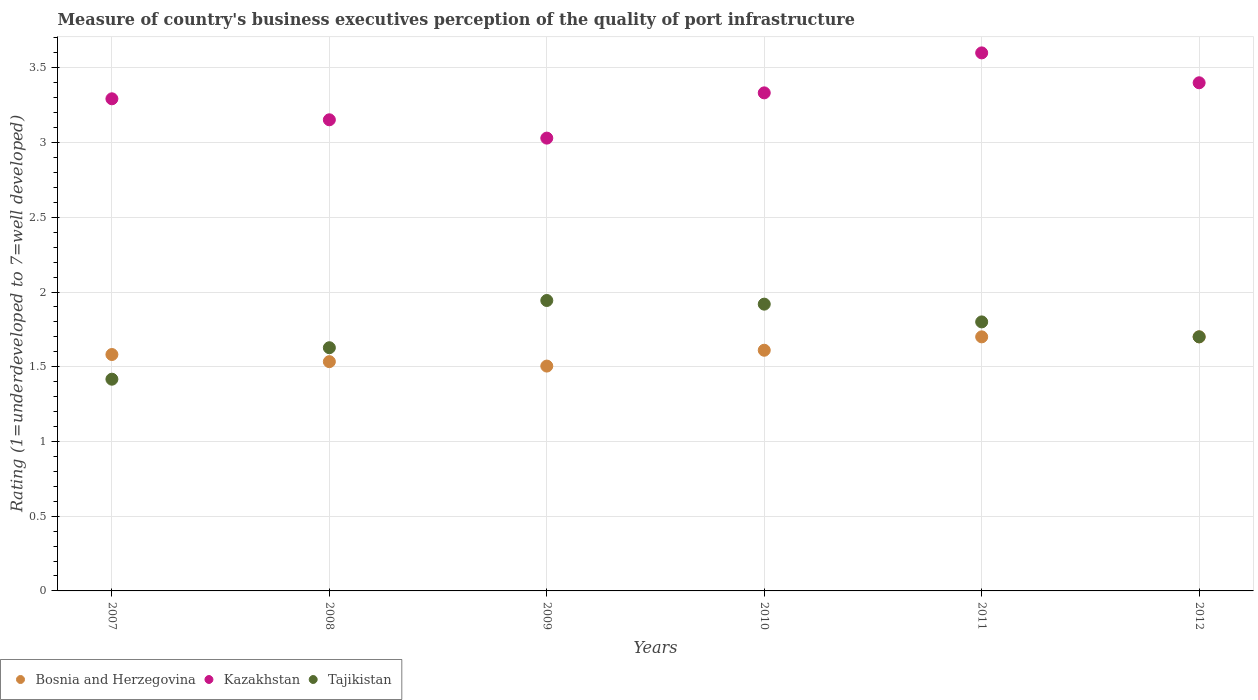How many different coloured dotlines are there?
Ensure brevity in your answer.  3. Is the number of dotlines equal to the number of legend labels?
Your answer should be very brief. Yes. What is the ratings of the quality of port infrastructure in Kazakhstan in 2007?
Offer a very short reply. 3.29. Across all years, what is the maximum ratings of the quality of port infrastructure in Tajikistan?
Give a very brief answer. 1.94. Across all years, what is the minimum ratings of the quality of port infrastructure in Tajikistan?
Your response must be concise. 1.42. In which year was the ratings of the quality of port infrastructure in Kazakhstan minimum?
Ensure brevity in your answer.  2009. What is the total ratings of the quality of port infrastructure in Bosnia and Herzegovina in the graph?
Ensure brevity in your answer.  9.63. What is the difference between the ratings of the quality of port infrastructure in Bosnia and Herzegovina in 2008 and that in 2010?
Provide a short and direct response. -0.08. What is the difference between the ratings of the quality of port infrastructure in Tajikistan in 2012 and the ratings of the quality of port infrastructure in Kazakhstan in 2009?
Offer a very short reply. -1.33. What is the average ratings of the quality of port infrastructure in Tajikistan per year?
Offer a very short reply. 1.73. In the year 2008, what is the difference between the ratings of the quality of port infrastructure in Kazakhstan and ratings of the quality of port infrastructure in Tajikistan?
Give a very brief answer. 1.53. What is the ratio of the ratings of the quality of port infrastructure in Bosnia and Herzegovina in 2009 to that in 2011?
Offer a terse response. 0.88. What is the difference between the highest and the second highest ratings of the quality of port infrastructure in Bosnia and Herzegovina?
Your answer should be very brief. 0. What is the difference between the highest and the lowest ratings of the quality of port infrastructure in Kazakhstan?
Provide a short and direct response. 0.57. Is the sum of the ratings of the quality of port infrastructure in Tajikistan in 2008 and 2009 greater than the maximum ratings of the quality of port infrastructure in Bosnia and Herzegovina across all years?
Make the answer very short. Yes. Does the ratings of the quality of port infrastructure in Bosnia and Herzegovina monotonically increase over the years?
Your answer should be very brief. No. Is the ratings of the quality of port infrastructure in Bosnia and Herzegovina strictly greater than the ratings of the quality of port infrastructure in Tajikistan over the years?
Your answer should be very brief. No. Is the ratings of the quality of port infrastructure in Bosnia and Herzegovina strictly less than the ratings of the quality of port infrastructure in Tajikistan over the years?
Make the answer very short. No. How many dotlines are there?
Provide a short and direct response. 3. How many years are there in the graph?
Your answer should be compact. 6. What is the difference between two consecutive major ticks on the Y-axis?
Provide a short and direct response. 0.5. Are the values on the major ticks of Y-axis written in scientific E-notation?
Your answer should be very brief. No. Does the graph contain grids?
Provide a succinct answer. Yes. What is the title of the graph?
Provide a succinct answer. Measure of country's business executives perception of the quality of port infrastructure. Does "Italy" appear as one of the legend labels in the graph?
Your response must be concise. No. What is the label or title of the Y-axis?
Keep it short and to the point. Rating (1=underdeveloped to 7=well developed). What is the Rating (1=underdeveloped to 7=well developed) of Bosnia and Herzegovina in 2007?
Make the answer very short. 1.58. What is the Rating (1=underdeveloped to 7=well developed) in Kazakhstan in 2007?
Ensure brevity in your answer.  3.29. What is the Rating (1=underdeveloped to 7=well developed) in Tajikistan in 2007?
Your answer should be compact. 1.42. What is the Rating (1=underdeveloped to 7=well developed) of Bosnia and Herzegovina in 2008?
Your answer should be compact. 1.53. What is the Rating (1=underdeveloped to 7=well developed) in Kazakhstan in 2008?
Provide a succinct answer. 3.15. What is the Rating (1=underdeveloped to 7=well developed) in Tajikistan in 2008?
Your answer should be very brief. 1.63. What is the Rating (1=underdeveloped to 7=well developed) of Bosnia and Herzegovina in 2009?
Offer a terse response. 1.5. What is the Rating (1=underdeveloped to 7=well developed) of Kazakhstan in 2009?
Provide a succinct answer. 3.03. What is the Rating (1=underdeveloped to 7=well developed) in Tajikistan in 2009?
Provide a short and direct response. 1.94. What is the Rating (1=underdeveloped to 7=well developed) of Bosnia and Herzegovina in 2010?
Keep it short and to the point. 1.61. What is the Rating (1=underdeveloped to 7=well developed) of Kazakhstan in 2010?
Offer a terse response. 3.33. What is the Rating (1=underdeveloped to 7=well developed) of Tajikistan in 2010?
Provide a succinct answer. 1.92. What is the Rating (1=underdeveloped to 7=well developed) in Bosnia and Herzegovina in 2011?
Your answer should be very brief. 1.7. Across all years, what is the maximum Rating (1=underdeveloped to 7=well developed) in Kazakhstan?
Ensure brevity in your answer.  3.6. Across all years, what is the maximum Rating (1=underdeveloped to 7=well developed) in Tajikistan?
Your answer should be compact. 1.94. Across all years, what is the minimum Rating (1=underdeveloped to 7=well developed) in Bosnia and Herzegovina?
Make the answer very short. 1.5. Across all years, what is the minimum Rating (1=underdeveloped to 7=well developed) of Kazakhstan?
Give a very brief answer. 3.03. Across all years, what is the minimum Rating (1=underdeveloped to 7=well developed) in Tajikistan?
Provide a short and direct response. 1.42. What is the total Rating (1=underdeveloped to 7=well developed) of Bosnia and Herzegovina in the graph?
Keep it short and to the point. 9.63. What is the total Rating (1=underdeveloped to 7=well developed) of Kazakhstan in the graph?
Provide a short and direct response. 19.81. What is the total Rating (1=underdeveloped to 7=well developed) in Tajikistan in the graph?
Give a very brief answer. 10.41. What is the difference between the Rating (1=underdeveloped to 7=well developed) of Bosnia and Herzegovina in 2007 and that in 2008?
Provide a short and direct response. 0.05. What is the difference between the Rating (1=underdeveloped to 7=well developed) in Kazakhstan in 2007 and that in 2008?
Offer a very short reply. 0.14. What is the difference between the Rating (1=underdeveloped to 7=well developed) of Tajikistan in 2007 and that in 2008?
Your answer should be compact. -0.21. What is the difference between the Rating (1=underdeveloped to 7=well developed) in Bosnia and Herzegovina in 2007 and that in 2009?
Ensure brevity in your answer.  0.08. What is the difference between the Rating (1=underdeveloped to 7=well developed) in Kazakhstan in 2007 and that in 2009?
Offer a very short reply. 0.26. What is the difference between the Rating (1=underdeveloped to 7=well developed) in Tajikistan in 2007 and that in 2009?
Keep it short and to the point. -0.53. What is the difference between the Rating (1=underdeveloped to 7=well developed) of Bosnia and Herzegovina in 2007 and that in 2010?
Keep it short and to the point. -0.03. What is the difference between the Rating (1=underdeveloped to 7=well developed) in Kazakhstan in 2007 and that in 2010?
Offer a very short reply. -0.04. What is the difference between the Rating (1=underdeveloped to 7=well developed) of Tajikistan in 2007 and that in 2010?
Provide a short and direct response. -0.5. What is the difference between the Rating (1=underdeveloped to 7=well developed) in Bosnia and Herzegovina in 2007 and that in 2011?
Keep it short and to the point. -0.12. What is the difference between the Rating (1=underdeveloped to 7=well developed) of Kazakhstan in 2007 and that in 2011?
Your answer should be compact. -0.31. What is the difference between the Rating (1=underdeveloped to 7=well developed) in Tajikistan in 2007 and that in 2011?
Your answer should be compact. -0.38. What is the difference between the Rating (1=underdeveloped to 7=well developed) in Bosnia and Herzegovina in 2007 and that in 2012?
Provide a short and direct response. -0.12. What is the difference between the Rating (1=underdeveloped to 7=well developed) of Kazakhstan in 2007 and that in 2012?
Make the answer very short. -0.11. What is the difference between the Rating (1=underdeveloped to 7=well developed) of Tajikistan in 2007 and that in 2012?
Make the answer very short. -0.28. What is the difference between the Rating (1=underdeveloped to 7=well developed) in Bosnia and Herzegovina in 2008 and that in 2009?
Your answer should be very brief. 0.03. What is the difference between the Rating (1=underdeveloped to 7=well developed) in Kazakhstan in 2008 and that in 2009?
Ensure brevity in your answer.  0.12. What is the difference between the Rating (1=underdeveloped to 7=well developed) in Tajikistan in 2008 and that in 2009?
Your answer should be compact. -0.32. What is the difference between the Rating (1=underdeveloped to 7=well developed) in Bosnia and Herzegovina in 2008 and that in 2010?
Provide a short and direct response. -0.08. What is the difference between the Rating (1=underdeveloped to 7=well developed) of Kazakhstan in 2008 and that in 2010?
Offer a terse response. -0.18. What is the difference between the Rating (1=underdeveloped to 7=well developed) in Tajikistan in 2008 and that in 2010?
Keep it short and to the point. -0.29. What is the difference between the Rating (1=underdeveloped to 7=well developed) of Bosnia and Herzegovina in 2008 and that in 2011?
Provide a succinct answer. -0.17. What is the difference between the Rating (1=underdeveloped to 7=well developed) in Kazakhstan in 2008 and that in 2011?
Offer a terse response. -0.45. What is the difference between the Rating (1=underdeveloped to 7=well developed) in Tajikistan in 2008 and that in 2011?
Give a very brief answer. -0.17. What is the difference between the Rating (1=underdeveloped to 7=well developed) in Bosnia and Herzegovina in 2008 and that in 2012?
Keep it short and to the point. -0.17. What is the difference between the Rating (1=underdeveloped to 7=well developed) of Kazakhstan in 2008 and that in 2012?
Offer a very short reply. -0.25. What is the difference between the Rating (1=underdeveloped to 7=well developed) of Tajikistan in 2008 and that in 2012?
Keep it short and to the point. -0.07. What is the difference between the Rating (1=underdeveloped to 7=well developed) of Bosnia and Herzegovina in 2009 and that in 2010?
Make the answer very short. -0.11. What is the difference between the Rating (1=underdeveloped to 7=well developed) of Kazakhstan in 2009 and that in 2010?
Your answer should be compact. -0.3. What is the difference between the Rating (1=underdeveloped to 7=well developed) of Tajikistan in 2009 and that in 2010?
Offer a terse response. 0.02. What is the difference between the Rating (1=underdeveloped to 7=well developed) in Bosnia and Herzegovina in 2009 and that in 2011?
Make the answer very short. -0.2. What is the difference between the Rating (1=underdeveloped to 7=well developed) in Kazakhstan in 2009 and that in 2011?
Offer a very short reply. -0.57. What is the difference between the Rating (1=underdeveloped to 7=well developed) of Tajikistan in 2009 and that in 2011?
Keep it short and to the point. 0.14. What is the difference between the Rating (1=underdeveloped to 7=well developed) of Bosnia and Herzegovina in 2009 and that in 2012?
Offer a very short reply. -0.2. What is the difference between the Rating (1=underdeveloped to 7=well developed) in Kazakhstan in 2009 and that in 2012?
Your response must be concise. -0.37. What is the difference between the Rating (1=underdeveloped to 7=well developed) in Tajikistan in 2009 and that in 2012?
Offer a terse response. 0.24. What is the difference between the Rating (1=underdeveloped to 7=well developed) of Bosnia and Herzegovina in 2010 and that in 2011?
Give a very brief answer. -0.09. What is the difference between the Rating (1=underdeveloped to 7=well developed) of Kazakhstan in 2010 and that in 2011?
Keep it short and to the point. -0.27. What is the difference between the Rating (1=underdeveloped to 7=well developed) of Tajikistan in 2010 and that in 2011?
Provide a short and direct response. 0.12. What is the difference between the Rating (1=underdeveloped to 7=well developed) of Bosnia and Herzegovina in 2010 and that in 2012?
Your answer should be very brief. -0.09. What is the difference between the Rating (1=underdeveloped to 7=well developed) in Kazakhstan in 2010 and that in 2012?
Ensure brevity in your answer.  -0.07. What is the difference between the Rating (1=underdeveloped to 7=well developed) in Tajikistan in 2010 and that in 2012?
Keep it short and to the point. 0.22. What is the difference between the Rating (1=underdeveloped to 7=well developed) in Bosnia and Herzegovina in 2011 and that in 2012?
Ensure brevity in your answer.  0. What is the difference between the Rating (1=underdeveloped to 7=well developed) in Bosnia and Herzegovina in 2007 and the Rating (1=underdeveloped to 7=well developed) in Kazakhstan in 2008?
Provide a short and direct response. -1.57. What is the difference between the Rating (1=underdeveloped to 7=well developed) in Bosnia and Herzegovina in 2007 and the Rating (1=underdeveloped to 7=well developed) in Tajikistan in 2008?
Provide a succinct answer. -0.05. What is the difference between the Rating (1=underdeveloped to 7=well developed) of Kazakhstan in 2007 and the Rating (1=underdeveloped to 7=well developed) of Tajikistan in 2008?
Your response must be concise. 1.67. What is the difference between the Rating (1=underdeveloped to 7=well developed) in Bosnia and Herzegovina in 2007 and the Rating (1=underdeveloped to 7=well developed) in Kazakhstan in 2009?
Your response must be concise. -1.45. What is the difference between the Rating (1=underdeveloped to 7=well developed) in Bosnia and Herzegovina in 2007 and the Rating (1=underdeveloped to 7=well developed) in Tajikistan in 2009?
Give a very brief answer. -0.36. What is the difference between the Rating (1=underdeveloped to 7=well developed) of Kazakhstan in 2007 and the Rating (1=underdeveloped to 7=well developed) of Tajikistan in 2009?
Give a very brief answer. 1.35. What is the difference between the Rating (1=underdeveloped to 7=well developed) in Bosnia and Herzegovina in 2007 and the Rating (1=underdeveloped to 7=well developed) in Kazakhstan in 2010?
Provide a succinct answer. -1.75. What is the difference between the Rating (1=underdeveloped to 7=well developed) of Bosnia and Herzegovina in 2007 and the Rating (1=underdeveloped to 7=well developed) of Tajikistan in 2010?
Your answer should be very brief. -0.34. What is the difference between the Rating (1=underdeveloped to 7=well developed) in Kazakhstan in 2007 and the Rating (1=underdeveloped to 7=well developed) in Tajikistan in 2010?
Offer a terse response. 1.37. What is the difference between the Rating (1=underdeveloped to 7=well developed) in Bosnia and Herzegovina in 2007 and the Rating (1=underdeveloped to 7=well developed) in Kazakhstan in 2011?
Your answer should be very brief. -2.02. What is the difference between the Rating (1=underdeveloped to 7=well developed) of Bosnia and Herzegovina in 2007 and the Rating (1=underdeveloped to 7=well developed) of Tajikistan in 2011?
Provide a succinct answer. -0.22. What is the difference between the Rating (1=underdeveloped to 7=well developed) in Kazakhstan in 2007 and the Rating (1=underdeveloped to 7=well developed) in Tajikistan in 2011?
Give a very brief answer. 1.49. What is the difference between the Rating (1=underdeveloped to 7=well developed) of Bosnia and Herzegovina in 2007 and the Rating (1=underdeveloped to 7=well developed) of Kazakhstan in 2012?
Provide a short and direct response. -1.82. What is the difference between the Rating (1=underdeveloped to 7=well developed) in Bosnia and Herzegovina in 2007 and the Rating (1=underdeveloped to 7=well developed) in Tajikistan in 2012?
Make the answer very short. -0.12. What is the difference between the Rating (1=underdeveloped to 7=well developed) in Kazakhstan in 2007 and the Rating (1=underdeveloped to 7=well developed) in Tajikistan in 2012?
Ensure brevity in your answer.  1.59. What is the difference between the Rating (1=underdeveloped to 7=well developed) of Bosnia and Herzegovina in 2008 and the Rating (1=underdeveloped to 7=well developed) of Kazakhstan in 2009?
Offer a terse response. -1.5. What is the difference between the Rating (1=underdeveloped to 7=well developed) in Bosnia and Herzegovina in 2008 and the Rating (1=underdeveloped to 7=well developed) in Tajikistan in 2009?
Provide a succinct answer. -0.41. What is the difference between the Rating (1=underdeveloped to 7=well developed) of Kazakhstan in 2008 and the Rating (1=underdeveloped to 7=well developed) of Tajikistan in 2009?
Your answer should be compact. 1.21. What is the difference between the Rating (1=underdeveloped to 7=well developed) of Bosnia and Herzegovina in 2008 and the Rating (1=underdeveloped to 7=well developed) of Kazakhstan in 2010?
Offer a terse response. -1.8. What is the difference between the Rating (1=underdeveloped to 7=well developed) in Bosnia and Herzegovina in 2008 and the Rating (1=underdeveloped to 7=well developed) in Tajikistan in 2010?
Provide a succinct answer. -0.38. What is the difference between the Rating (1=underdeveloped to 7=well developed) of Kazakhstan in 2008 and the Rating (1=underdeveloped to 7=well developed) of Tajikistan in 2010?
Keep it short and to the point. 1.23. What is the difference between the Rating (1=underdeveloped to 7=well developed) in Bosnia and Herzegovina in 2008 and the Rating (1=underdeveloped to 7=well developed) in Kazakhstan in 2011?
Your response must be concise. -2.07. What is the difference between the Rating (1=underdeveloped to 7=well developed) in Bosnia and Herzegovina in 2008 and the Rating (1=underdeveloped to 7=well developed) in Tajikistan in 2011?
Your answer should be very brief. -0.27. What is the difference between the Rating (1=underdeveloped to 7=well developed) in Kazakhstan in 2008 and the Rating (1=underdeveloped to 7=well developed) in Tajikistan in 2011?
Provide a short and direct response. 1.35. What is the difference between the Rating (1=underdeveloped to 7=well developed) in Bosnia and Herzegovina in 2008 and the Rating (1=underdeveloped to 7=well developed) in Kazakhstan in 2012?
Offer a terse response. -1.87. What is the difference between the Rating (1=underdeveloped to 7=well developed) of Bosnia and Herzegovina in 2008 and the Rating (1=underdeveloped to 7=well developed) of Tajikistan in 2012?
Keep it short and to the point. -0.17. What is the difference between the Rating (1=underdeveloped to 7=well developed) of Kazakhstan in 2008 and the Rating (1=underdeveloped to 7=well developed) of Tajikistan in 2012?
Ensure brevity in your answer.  1.45. What is the difference between the Rating (1=underdeveloped to 7=well developed) in Bosnia and Herzegovina in 2009 and the Rating (1=underdeveloped to 7=well developed) in Kazakhstan in 2010?
Keep it short and to the point. -1.83. What is the difference between the Rating (1=underdeveloped to 7=well developed) of Bosnia and Herzegovina in 2009 and the Rating (1=underdeveloped to 7=well developed) of Tajikistan in 2010?
Your answer should be very brief. -0.41. What is the difference between the Rating (1=underdeveloped to 7=well developed) in Kazakhstan in 2009 and the Rating (1=underdeveloped to 7=well developed) in Tajikistan in 2010?
Ensure brevity in your answer.  1.11. What is the difference between the Rating (1=underdeveloped to 7=well developed) in Bosnia and Herzegovina in 2009 and the Rating (1=underdeveloped to 7=well developed) in Kazakhstan in 2011?
Your answer should be very brief. -2.1. What is the difference between the Rating (1=underdeveloped to 7=well developed) of Bosnia and Herzegovina in 2009 and the Rating (1=underdeveloped to 7=well developed) of Tajikistan in 2011?
Offer a very short reply. -0.3. What is the difference between the Rating (1=underdeveloped to 7=well developed) of Kazakhstan in 2009 and the Rating (1=underdeveloped to 7=well developed) of Tajikistan in 2011?
Keep it short and to the point. 1.23. What is the difference between the Rating (1=underdeveloped to 7=well developed) in Bosnia and Herzegovina in 2009 and the Rating (1=underdeveloped to 7=well developed) in Kazakhstan in 2012?
Your response must be concise. -1.9. What is the difference between the Rating (1=underdeveloped to 7=well developed) in Bosnia and Herzegovina in 2009 and the Rating (1=underdeveloped to 7=well developed) in Tajikistan in 2012?
Offer a very short reply. -0.2. What is the difference between the Rating (1=underdeveloped to 7=well developed) in Kazakhstan in 2009 and the Rating (1=underdeveloped to 7=well developed) in Tajikistan in 2012?
Keep it short and to the point. 1.33. What is the difference between the Rating (1=underdeveloped to 7=well developed) of Bosnia and Herzegovina in 2010 and the Rating (1=underdeveloped to 7=well developed) of Kazakhstan in 2011?
Offer a terse response. -1.99. What is the difference between the Rating (1=underdeveloped to 7=well developed) in Bosnia and Herzegovina in 2010 and the Rating (1=underdeveloped to 7=well developed) in Tajikistan in 2011?
Ensure brevity in your answer.  -0.19. What is the difference between the Rating (1=underdeveloped to 7=well developed) in Kazakhstan in 2010 and the Rating (1=underdeveloped to 7=well developed) in Tajikistan in 2011?
Your answer should be very brief. 1.53. What is the difference between the Rating (1=underdeveloped to 7=well developed) in Bosnia and Herzegovina in 2010 and the Rating (1=underdeveloped to 7=well developed) in Kazakhstan in 2012?
Your answer should be very brief. -1.79. What is the difference between the Rating (1=underdeveloped to 7=well developed) in Bosnia and Herzegovina in 2010 and the Rating (1=underdeveloped to 7=well developed) in Tajikistan in 2012?
Your answer should be very brief. -0.09. What is the difference between the Rating (1=underdeveloped to 7=well developed) of Kazakhstan in 2010 and the Rating (1=underdeveloped to 7=well developed) of Tajikistan in 2012?
Your response must be concise. 1.63. What is the difference between the Rating (1=underdeveloped to 7=well developed) in Bosnia and Herzegovina in 2011 and the Rating (1=underdeveloped to 7=well developed) in Tajikistan in 2012?
Your answer should be compact. 0. What is the difference between the Rating (1=underdeveloped to 7=well developed) in Kazakhstan in 2011 and the Rating (1=underdeveloped to 7=well developed) in Tajikistan in 2012?
Your answer should be very brief. 1.9. What is the average Rating (1=underdeveloped to 7=well developed) in Bosnia and Herzegovina per year?
Make the answer very short. 1.61. What is the average Rating (1=underdeveloped to 7=well developed) of Kazakhstan per year?
Make the answer very short. 3.3. What is the average Rating (1=underdeveloped to 7=well developed) in Tajikistan per year?
Your answer should be compact. 1.73. In the year 2007, what is the difference between the Rating (1=underdeveloped to 7=well developed) of Bosnia and Herzegovina and Rating (1=underdeveloped to 7=well developed) of Kazakhstan?
Ensure brevity in your answer.  -1.71. In the year 2007, what is the difference between the Rating (1=underdeveloped to 7=well developed) in Bosnia and Herzegovina and Rating (1=underdeveloped to 7=well developed) in Tajikistan?
Make the answer very short. 0.17. In the year 2007, what is the difference between the Rating (1=underdeveloped to 7=well developed) in Kazakhstan and Rating (1=underdeveloped to 7=well developed) in Tajikistan?
Your answer should be compact. 1.88. In the year 2008, what is the difference between the Rating (1=underdeveloped to 7=well developed) of Bosnia and Herzegovina and Rating (1=underdeveloped to 7=well developed) of Kazakhstan?
Your answer should be compact. -1.62. In the year 2008, what is the difference between the Rating (1=underdeveloped to 7=well developed) in Bosnia and Herzegovina and Rating (1=underdeveloped to 7=well developed) in Tajikistan?
Your answer should be very brief. -0.09. In the year 2008, what is the difference between the Rating (1=underdeveloped to 7=well developed) of Kazakhstan and Rating (1=underdeveloped to 7=well developed) of Tajikistan?
Provide a succinct answer. 1.53. In the year 2009, what is the difference between the Rating (1=underdeveloped to 7=well developed) in Bosnia and Herzegovina and Rating (1=underdeveloped to 7=well developed) in Kazakhstan?
Offer a terse response. -1.53. In the year 2009, what is the difference between the Rating (1=underdeveloped to 7=well developed) in Bosnia and Herzegovina and Rating (1=underdeveloped to 7=well developed) in Tajikistan?
Keep it short and to the point. -0.44. In the year 2009, what is the difference between the Rating (1=underdeveloped to 7=well developed) of Kazakhstan and Rating (1=underdeveloped to 7=well developed) of Tajikistan?
Offer a very short reply. 1.09. In the year 2010, what is the difference between the Rating (1=underdeveloped to 7=well developed) in Bosnia and Herzegovina and Rating (1=underdeveloped to 7=well developed) in Kazakhstan?
Ensure brevity in your answer.  -1.72. In the year 2010, what is the difference between the Rating (1=underdeveloped to 7=well developed) of Bosnia and Herzegovina and Rating (1=underdeveloped to 7=well developed) of Tajikistan?
Give a very brief answer. -0.31. In the year 2010, what is the difference between the Rating (1=underdeveloped to 7=well developed) in Kazakhstan and Rating (1=underdeveloped to 7=well developed) in Tajikistan?
Ensure brevity in your answer.  1.41. In the year 2011, what is the difference between the Rating (1=underdeveloped to 7=well developed) in Bosnia and Herzegovina and Rating (1=underdeveloped to 7=well developed) in Kazakhstan?
Keep it short and to the point. -1.9. In the year 2012, what is the difference between the Rating (1=underdeveloped to 7=well developed) of Bosnia and Herzegovina and Rating (1=underdeveloped to 7=well developed) of Kazakhstan?
Your response must be concise. -1.7. In the year 2012, what is the difference between the Rating (1=underdeveloped to 7=well developed) in Bosnia and Herzegovina and Rating (1=underdeveloped to 7=well developed) in Tajikistan?
Make the answer very short. 0. What is the ratio of the Rating (1=underdeveloped to 7=well developed) in Bosnia and Herzegovina in 2007 to that in 2008?
Ensure brevity in your answer.  1.03. What is the ratio of the Rating (1=underdeveloped to 7=well developed) in Kazakhstan in 2007 to that in 2008?
Your response must be concise. 1.04. What is the ratio of the Rating (1=underdeveloped to 7=well developed) in Tajikistan in 2007 to that in 2008?
Your answer should be compact. 0.87. What is the ratio of the Rating (1=underdeveloped to 7=well developed) in Bosnia and Herzegovina in 2007 to that in 2009?
Make the answer very short. 1.05. What is the ratio of the Rating (1=underdeveloped to 7=well developed) of Kazakhstan in 2007 to that in 2009?
Your answer should be compact. 1.09. What is the ratio of the Rating (1=underdeveloped to 7=well developed) in Tajikistan in 2007 to that in 2009?
Provide a short and direct response. 0.73. What is the ratio of the Rating (1=underdeveloped to 7=well developed) in Bosnia and Herzegovina in 2007 to that in 2010?
Give a very brief answer. 0.98. What is the ratio of the Rating (1=underdeveloped to 7=well developed) in Kazakhstan in 2007 to that in 2010?
Ensure brevity in your answer.  0.99. What is the ratio of the Rating (1=underdeveloped to 7=well developed) of Tajikistan in 2007 to that in 2010?
Offer a very short reply. 0.74. What is the ratio of the Rating (1=underdeveloped to 7=well developed) in Bosnia and Herzegovina in 2007 to that in 2011?
Provide a short and direct response. 0.93. What is the ratio of the Rating (1=underdeveloped to 7=well developed) of Kazakhstan in 2007 to that in 2011?
Ensure brevity in your answer.  0.91. What is the ratio of the Rating (1=underdeveloped to 7=well developed) in Tajikistan in 2007 to that in 2011?
Keep it short and to the point. 0.79. What is the ratio of the Rating (1=underdeveloped to 7=well developed) of Bosnia and Herzegovina in 2007 to that in 2012?
Ensure brevity in your answer.  0.93. What is the ratio of the Rating (1=underdeveloped to 7=well developed) in Kazakhstan in 2007 to that in 2012?
Make the answer very short. 0.97. What is the ratio of the Rating (1=underdeveloped to 7=well developed) of Tajikistan in 2007 to that in 2012?
Provide a succinct answer. 0.83. What is the ratio of the Rating (1=underdeveloped to 7=well developed) of Bosnia and Herzegovina in 2008 to that in 2009?
Provide a short and direct response. 1.02. What is the ratio of the Rating (1=underdeveloped to 7=well developed) in Kazakhstan in 2008 to that in 2009?
Provide a short and direct response. 1.04. What is the ratio of the Rating (1=underdeveloped to 7=well developed) of Tajikistan in 2008 to that in 2009?
Your answer should be very brief. 0.84. What is the ratio of the Rating (1=underdeveloped to 7=well developed) in Bosnia and Herzegovina in 2008 to that in 2010?
Ensure brevity in your answer.  0.95. What is the ratio of the Rating (1=underdeveloped to 7=well developed) of Kazakhstan in 2008 to that in 2010?
Your answer should be very brief. 0.95. What is the ratio of the Rating (1=underdeveloped to 7=well developed) of Tajikistan in 2008 to that in 2010?
Give a very brief answer. 0.85. What is the ratio of the Rating (1=underdeveloped to 7=well developed) of Bosnia and Herzegovina in 2008 to that in 2011?
Provide a short and direct response. 0.9. What is the ratio of the Rating (1=underdeveloped to 7=well developed) in Kazakhstan in 2008 to that in 2011?
Your answer should be compact. 0.88. What is the ratio of the Rating (1=underdeveloped to 7=well developed) in Tajikistan in 2008 to that in 2011?
Your answer should be very brief. 0.9. What is the ratio of the Rating (1=underdeveloped to 7=well developed) of Bosnia and Herzegovina in 2008 to that in 2012?
Offer a terse response. 0.9. What is the ratio of the Rating (1=underdeveloped to 7=well developed) of Kazakhstan in 2008 to that in 2012?
Offer a terse response. 0.93. What is the ratio of the Rating (1=underdeveloped to 7=well developed) in Tajikistan in 2008 to that in 2012?
Provide a succinct answer. 0.96. What is the ratio of the Rating (1=underdeveloped to 7=well developed) of Bosnia and Herzegovina in 2009 to that in 2010?
Ensure brevity in your answer.  0.93. What is the ratio of the Rating (1=underdeveloped to 7=well developed) in Kazakhstan in 2009 to that in 2010?
Ensure brevity in your answer.  0.91. What is the ratio of the Rating (1=underdeveloped to 7=well developed) in Tajikistan in 2009 to that in 2010?
Offer a terse response. 1.01. What is the ratio of the Rating (1=underdeveloped to 7=well developed) of Bosnia and Herzegovina in 2009 to that in 2011?
Offer a very short reply. 0.89. What is the ratio of the Rating (1=underdeveloped to 7=well developed) in Kazakhstan in 2009 to that in 2011?
Offer a terse response. 0.84. What is the ratio of the Rating (1=underdeveloped to 7=well developed) of Tajikistan in 2009 to that in 2011?
Provide a succinct answer. 1.08. What is the ratio of the Rating (1=underdeveloped to 7=well developed) of Bosnia and Herzegovina in 2009 to that in 2012?
Your response must be concise. 0.89. What is the ratio of the Rating (1=underdeveloped to 7=well developed) of Kazakhstan in 2009 to that in 2012?
Make the answer very short. 0.89. What is the ratio of the Rating (1=underdeveloped to 7=well developed) of Tajikistan in 2009 to that in 2012?
Ensure brevity in your answer.  1.14. What is the ratio of the Rating (1=underdeveloped to 7=well developed) in Bosnia and Herzegovina in 2010 to that in 2011?
Keep it short and to the point. 0.95. What is the ratio of the Rating (1=underdeveloped to 7=well developed) in Kazakhstan in 2010 to that in 2011?
Your answer should be compact. 0.93. What is the ratio of the Rating (1=underdeveloped to 7=well developed) of Tajikistan in 2010 to that in 2011?
Provide a short and direct response. 1.07. What is the ratio of the Rating (1=underdeveloped to 7=well developed) in Bosnia and Herzegovina in 2010 to that in 2012?
Offer a terse response. 0.95. What is the ratio of the Rating (1=underdeveloped to 7=well developed) of Kazakhstan in 2010 to that in 2012?
Your answer should be very brief. 0.98. What is the ratio of the Rating (1=underdeveloped to 7=well developed) of Tajikistan in 2010 to that in 2012?
Provide a short and direct response. 1.13. What is the ratio of the Rating (1=underdeveloped to 7=well developed) of Bosnia and Herzegovina in 2011 to that in 2012?
Offer a very short reply. 1. What is the ratio of the Rating (1=underdeveloped to 7=well developed) of Kazakhstan in 2011 to that in 2012?
Ensure brevity in your answer.  1.06. What is the ratio of the Rating (1=underdeveloped to 7=well developed) in Tajikistan in 2011 to that in 2012?
Ensure brevity in your answer.  1.06. What is the difference between the highest and the second highest Rating (1=underdeveloped to 7=well developed) in Bosnia and Herzegovina?
Offer a terse response. 0. What is the difference between the highest and the second highest Rating (1=underdeveloped to 7=well developed) in Kazakhstan?
Make the answer very short. 0.2. What is the difference between the highest and the second highest Rating (1=underdeveloped to 7=well developed) in Tajikistan?
Your answer should be very brief. 0.02. What is the difference between the highest and the lowest Rating (1=underdeveloped to 7=well developed) of Bosnia and Herzegovina?
Offer a terse response. 0.2. What is the difference between the highest and the lowest Rating (1=underdeveloped to 7=well developed) of Kazakhstan?
Provide a short and direct response. 0.57. What is the difference between the highest and the lowest Rating (1=underdeveloped to 7=well developed) of Tajikistan?
Keep it short and to the point. 0.53. 